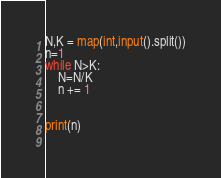<code> <loc_0><loc_0><loc_500><loc_500><_Python_>N,K = map(int,input().split())
n=1
while N>K:
	N=N/K
	n += 1


print(n)
	
</code> 